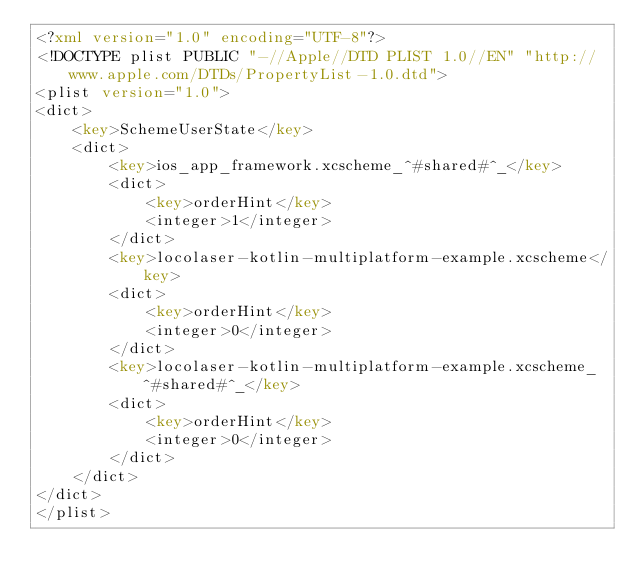<code> <loc_0><loc_0><loc_500><loc_500><_XML_><?xml version="1.0" encoding="UTF-8"?>
<!DOCTYPE plist PUBLIC "-//Apple//DTD PLIST 1.0//EN" "http://www.apple.com/DTDs/PropertyList-1.0.dtd">
<plist version="1.0">
<dict>
	<key>SchemeUserState</key>
	<dict>
		<key>ios_app_framework.xcscheme_^#shared#^_</key>
		<dict>
			<key>orderHint</key>
			<integer>1</integer>
		</dict>
		<key>locolaser-kotlin-multiplatform-example.xcscheme</key>
		<dict>
			<key>orderHint</key>
			<integer>0</integer>
		</dict>
		<key>locolaser-kotlin-multiplatform-example.xcscheme_^#shared#^_</key>
		<dict>
			<key>orderHint</key>
			<integer>0</integer>
		</dict>
	</dict>
</dict>
</plist>
</code> 